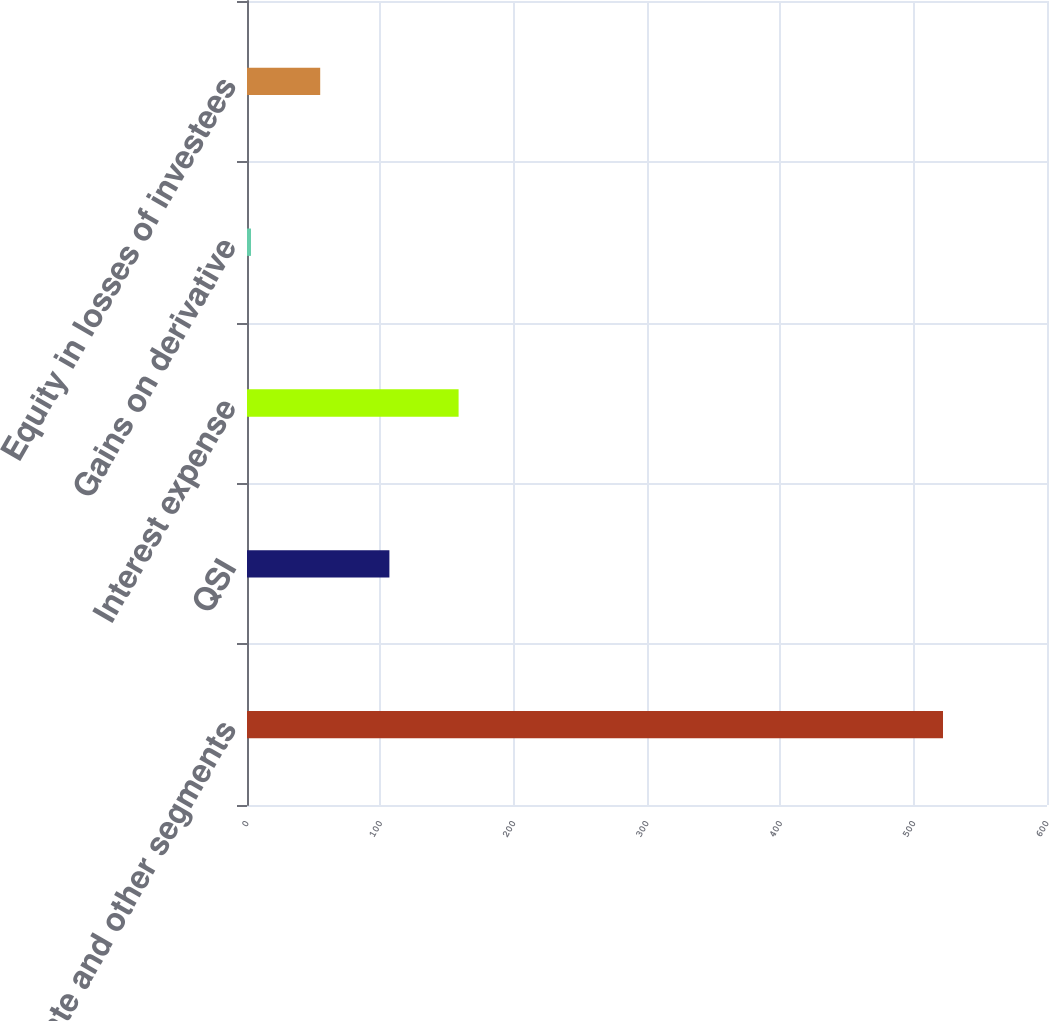Convert chart. <chart><loc_0><loc_0><loc_500><loc_500><bar_chart><fcel>Corporate and other segments<fcel>QSI<fcel>Interest expense<fcel>Gains on derivative<fcel>Equity in losses of investees<nl><fcel>522<fcel>106.8<fcel>158.7<fcel>3<fcel>54.9<nl></chart> 